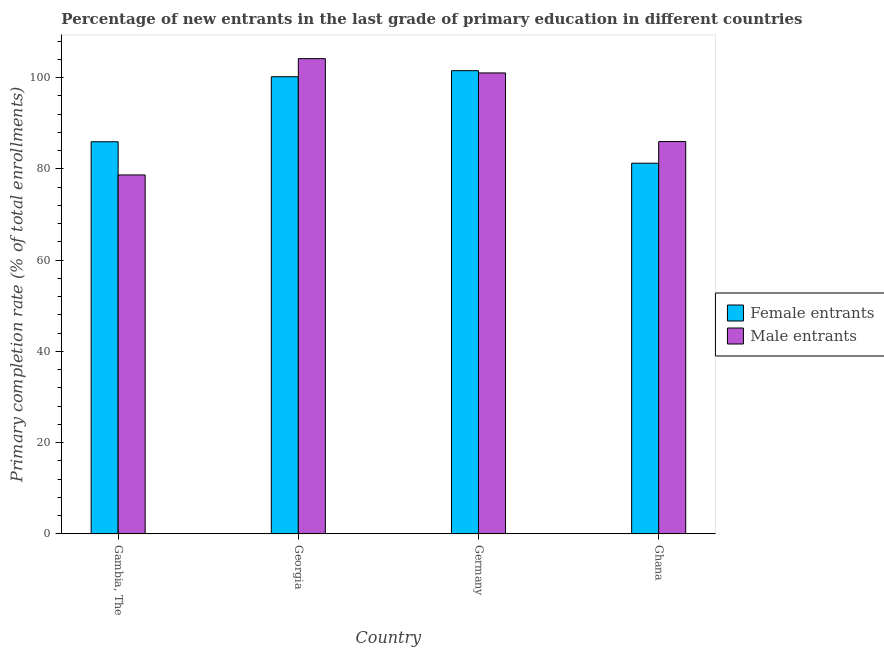How many groups of bars are there?
Your answer should be very brief. 4. Are the number of bars on each tick of the X-axis equal?
Your answer should be very brief. Yes. How many bars are there on the 1st tick from the left?
Your answer should be very brief. 2. What is the label of the 1st group of bars from the left?
Make the answer very short. Gambia, The. What is the primary completion rate of female entrants in Gambia, The?
Offer a terse response. 85.94. Across all countries, what is the maximum primary completion rate of female entrants?
Offer a very short reply. 101.53. Across all countries, what is the minimum primary completion rate of male entrants?
Provide a short and direct response. 78.67. In which country was the primary completion rate of male entrants maximum?
Your response must be concise. Georgia. In which country was the primary completion rate of female entrants minimum?
Your answer should be compact. Ghana. What is the total primary completion rate of female entrants in the graph?
Your answer should be very brief. 368.9. What is the difference between the primary completion rate of male entrants in Gambia, The and that in Georgia?
Your answer should be compact. -25.49. What is the difference between the primary completion rate of female entrants in Georgia and the primary completion rate of male entrants in Germany?
Your response must be concise. -0.84. What is the average primary completion rate of male entrants per country?
Provide a short and direct response. 92.46. What is the difference between the primary completion rate of female entrants and primary completion rate of male entrants in Ghana?
Provide a succinct answer. -4.75. In how many countries, is the primary completion rate of male entrants greater than 8 %?
Offer a very short reply. 4. What is the ratio of the primary completion rate of female entrants in Germany to that in Ghana?
Offer a terse response. 1.25. Is the primary completion rate of male entrants in Gambia, The less than that in Germany?
Your response must be concise. Yes. What is the difference between the highest and the second highest primary completion rate of male entrants?
Provide a short and direct response. 3.13. What is the difference between the highest and the lowest primary completion rate of male entrants?
Your answer should be compact. 25.49. In how many countries, is the primary completion rate of male entrants greater than the average primary completion rate of male entrants taken over all countries?
Provide a succinct answer. 2. What does the 2nd bar from the left in Georgia represents?
Your response must be concise. Male entrants. What does the 1st bar from the right in Germany represents?
Offer a terse response. Male entrants. How many bars are there?
Give a very brief answer. 8. What is the difference between two consecutive major ticks on the Y-axis?
Make the answer very short. 20. Are the values on the major ticks of Y-axis written in scientific E-notation?
Make the answer very short. No. Does the graph contain any zero values?
Keep it short and to the point. No. Does the graph contain grids?
Provide a short and direct response. No. Where does the legend appear in the graph?
Your response must be concise. Center right. How many legend labels are there?
Give a very brief answer. 2. How are the legend labels stacked?
Offer a terse response. Vertical. What is the title of the graph?
Provide a short and direct response. Percentage of new entrants in the last grade of primary education in different countries. What is the label or title of the Y-axis?
Make the answer very short. Primary completion rate (% of total enrollments). What is the Primary completion rate (% of total enrollments) of Female entrants in Gambia, The?
Your answer should be very brief. 85.94. What is the Primary completion rate (% of total enrollments) of Male entrants in Gambia, The?
Provide a succinct answer. 78.67. What is the Primary completion rate (% of total enrollments) of Female entrants in Georgia?
Offer a very short reply. 100.19. What is the Primary completion rate (% of total enrollments) in Male entrants in Georgia?
Offer a terse response. 104.16. What is the Primary completion rate (% of total enrollments) of Female entrants in Germany?
Your response must be concise. 101.53. What is the Primary completion rate (% of total enrollments) of Male entrants in Germany?
Provide a succinct answer. 101.03. What is the Primary completion rate (% of total enrollments) in Female entrants in Ghana?
Your answer should be very brief. 81.24. What is the Primary completion rate (% of total enrollments) of Male entrants in Ghana?
Your answer should be very brief. 85.99. Across all countries, what is the maximum Primary completion rate (% of total enrollments) in Female entrants?
Keep it short and to the point. 101.53. Across all countries, what is the maximum Primary completion rate (% of total enrollments) in Male entrants?
Offer a very short reply. 104.16. Across all countries, what is the minimum Primary completion rate (% of total enrollments) of Female entrants?
Provide a succinct answer. 81.24. Across all countries, what is the minimum Primary completion rate (% of total enrollments) in Male entrants?
Your answer should be compact. 78.67. What is the total Primary completion rate (% of total enrollments) in Female entrants in the graph?
Provide a succinct answer. 368.9. What is the total Primary completion rate (% of total enrollments) in Male entrants in the graph?
Your answer should be very brief. 369.86. What is the difference between the Primary completion rate (% of total enrollments) in Female entrants in Gambia, The and that in Georgia?
Offer a terse response. -14.25. What is the difference between the Primary completion rate (% of total enrollments) of Male entrants in Gambia, The and that in Georgia?
Provide a succinct answer. -25.49. What is the difference between the Primary completion rate (% of total enrollments) of Female entrants in Gambia, The and that in Germany?
Give a very brief answer. -15.58. What is the difference between the Primary completion rate (% of total enrollments) of Male entrants in Gambia, The and that in Germany?
Offer a very short reply. -22.36. What is the difference between the Primary completion rate (% of total enrollments) of Female entrants in Gambia, The and that in Ghana?
Provide a succinct answer. 4.7. What is the difference between the Primary completion rate (% of total enrollments) of Male entrants in Gambia, The and that in Ghana?
Offer a terse response. -7.32. What is the difference between the Primary completion rate (% of total enrollments) in Female entrants in Georgia and that in Germany?
Give a very brief answer. -1.33. What is the difference between the Primary completion rate (% of total enrollments) of Male entrants in Georgia and that in Germany?
Your answer should be very brief. 3.13. What is the difference between the Primary completion rate (% of total enrollments) in Female entrants in Georgia and that in Ghana?
Your response must be concise. 18.96. What is the difference between the Primary completion rate (% of total enrollments) in Male entrants in Georgia and that in Ghana?
Give a very brief answer. 18.18. What is the difference between the Primary completion rate (% of total enrollments) of Female entrants in Germany and that in Ghana?
Ensure brevity in your answer.  20.29. What is the difference between the Primary completion rate (% of total enrollments) in Male entrants in Germany and that in Ghana?
Make the answer very short. 15.04. What is the difference between the Primary completion rate (% of total enrollments) of Female entrants in Gambia, The and the Primary completion rate (% of total enrollments) of Male entrants in Georgia?
Offer a very short reply. -18.22. What is the difference between the Primary completion rate (% of total enrollments) of Female entrants in Gambia, The and the Primary completion rate (% of total enrollments) of Male entrants in Germany?
Your answer should be very brief. -15.09. What is the difference between the Primary completion rate (% of total enrollments) of Female entrants in Gambia, The and the Primary completion rate (% of total enrollments) of Male entrants in Ghana?
Make the answer very short. -0.05. What is the difference between the Primary completion rate (% of total enrollments) in Female entrants in Georgia and the Primary completion rate (% of total enrollments) in Male entrants in Germany?
Provide a short and direct response. -0.84. What is the difference between the Primary completion rate (% of total enrollments) of Female entrants in Georgia and the Primary completion rate (% of total enrollments) of Male entrants in Ghana?
Provide a short and direct response. 14.21. What is the difference between the Primary completion rate (% of total enrollments) in Female entrants in Germany and the Primary completion rate (% of total enrollments) in Male entrants in Ghana?
Make the answer very short. 15.54. What is the average Primary completion rate (% of total enrollments) of Female entrants per country?
Give a very brief answer. 92.23. What is the average Primary completion rate (% of total enrollments) of Male entrants per country?
Give a very brief answer. 92.46. What is the difference between the Primary completion rate (% of total enrollments) of Female entrants and Primary completion rate (% of total enrollments) of Male entrants in Gambia, The?
Give a very brief answer. 7.27. What is the difference between the Primary completion rate (% of total enrollments) in Female entrants and Primary completion rate (% of total enrollments) in Male entrants in Georgia?
Make the answer very short. -3.97. What is the difference between the Primary completion rate (% of total enrollments) in Female entrants and Primary completion rate (% of total enrollments) in Male entrants in Germany?
Provide a succinct answer. 0.49. What is the difference between the Primary completion rate (% of total enrollments) of Female entrants and Primary completion rate (% of total enrollments) of Male entrants in Ghana?
Keep it short and to the point. -4.75. What is the ratio of the Primary completion rate (% of total enrollments) in Female entrants in Gambia, The to that in Georgia?
Provide a succinct answer. 0.86. What is the ratio of the Primary completion rate (% of total enrollments) in Male entrants in Gambia, The to that in Georgia?
Ensure brevity in your answer.  0.76. What is the ratio of the Primary completion rate (% of total enrollments) of Female entrants in Gambia, The to that in Germany?
Provide a succinct answer. 0.85. What is the ratio of the Primary completion rate (% of total enrollments) of Male entrants in Gambia, The to that in Germany?
Your answer should be compact. 0.78. What is the ratio of the Primary completion rate (% of total enrollments) of Female entrants in Gambia, The to that in Ghana?
Offer a terse response. 1.06. What is the ratio of the Primary completion rate (% of total enrollments) in Male entrants in Gambia, The to that in Ghana?
Offer a very short reply. 0.91. What is the ratio of the Primary completion rate (% of total enrollments) in Female entrants in Georgia to that in Germany?
Provide a short and direct response. 0.99. What is the ratio of the Primary completion rate (% of total enrollments) in Male entrants in Georgia to that in Germany?
Ensure brevity in your answer.  1.03. What is the ratio of the Primary completion rate (% of total enrollments) of Female entrants in Georgia to that in Ghana?
Ensure brevity in your answer.  1.23. What is the ratio of the Primary completion rate (% of total enrollments) in Male entrants in Georgia to that in Ghana?
Offer a very short reply. 1.21. What is the ratio of the Primary completion rate (% of total enrollments) in Female entrants in Germany to that in Ghana?
Make the answer very short. 1.25. What is the ratio of the Primary completion rate (% of total enrollments) in Male entrants in Germany to that in Ghana?
Your answer should be very brief. 1.18. What is the difference between the highest and the second highest Primary completion rate (% of total enrollments) of Female entrants?
Make the answer very short. 1.33. What is the difference between the highest and the second highest Primary completion rate (% of total enrollments) of Male entrants?
Offer a terse response. 3.13. What is the difference between the highest and the lowest Primary completion rate (% of total enrollments) in Female entrants?
Ensure brevity in your answer.  20.29. What is the difference between the highest and the lowest Primary completion rate (% of total enrollments) of Male entrants?
Keep it short and to the point. 25.49. 